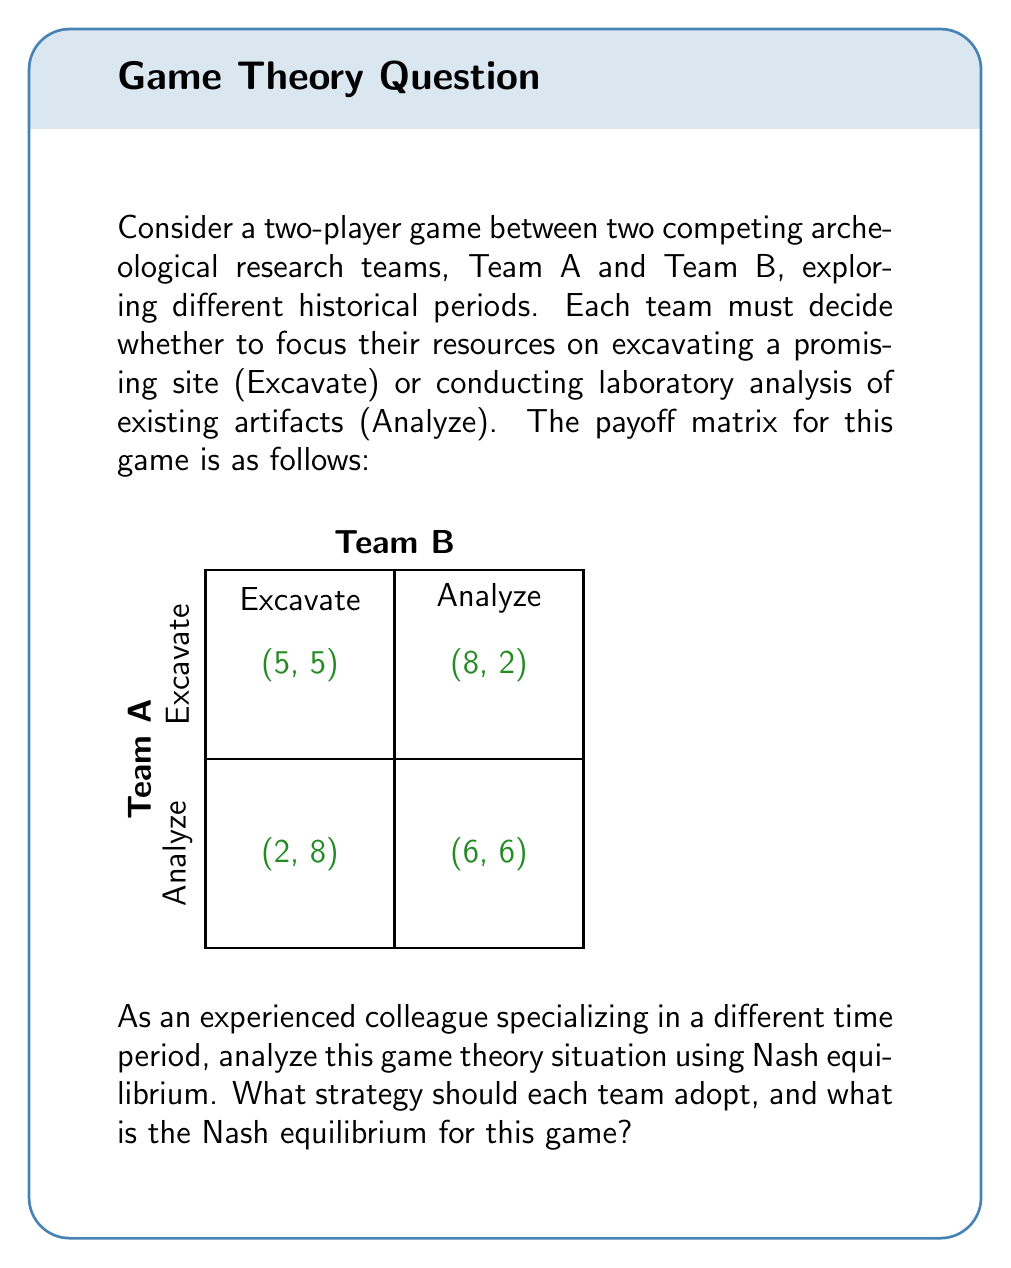Give your solution to this math problem. To find the Nash equilibrium, we need to determine the best response for each player given the other player's strategy. Let's analyze this step-by-step:

1. For Team A:
   - If Team B chooses Excavate:
     Team A gets 5 for Excavate, 2 for Analyze. Best response: Excavate
   - If Team B chooses Analyze:
     Team A gets 8 for Excavate, 6 for Analyze. Best response: Excavate

2. For Team B:
   - If Team A chooses Excavate:
     Team B gets 5 for Excavate, 2 for Analyze. Best response: Excavate
   - If Team A chooses Analyze:
     Team B gets 8 for Excavate, 6 for Analyze. Best response: Excavate

3. Nash equilibrium definition: A set of strategies where no player can unilaterally change their strategy to increase their payoff.

4. From the analysis, we can see that regardless of what the other team does, both Team A and Team B always have Excavate as their best response.

5. Therefore, the Nash equilibrium for this game is (Excavate, Excavate), resulting in a payoff of (5, 5).

6. This is a dominant strategy equilibrium, as Excavate is the dominant strategy for both players.

7. Interpretation in the context of archeological research:
   - Both teams choosing to excavate represents a focus on field work and new discoveries.
   - This equilibrium suggests that in the competitive environment, teams are incentivized to prioritize new findings over analyzing existing artifacts.
   - However, this may not be the most efficient outcome for the field as a whole, as it could lead to neglect of important laboratory analysis.
Answer: Nash equilibrium: (Excavate, Excavate) with payoff (5, 5) 